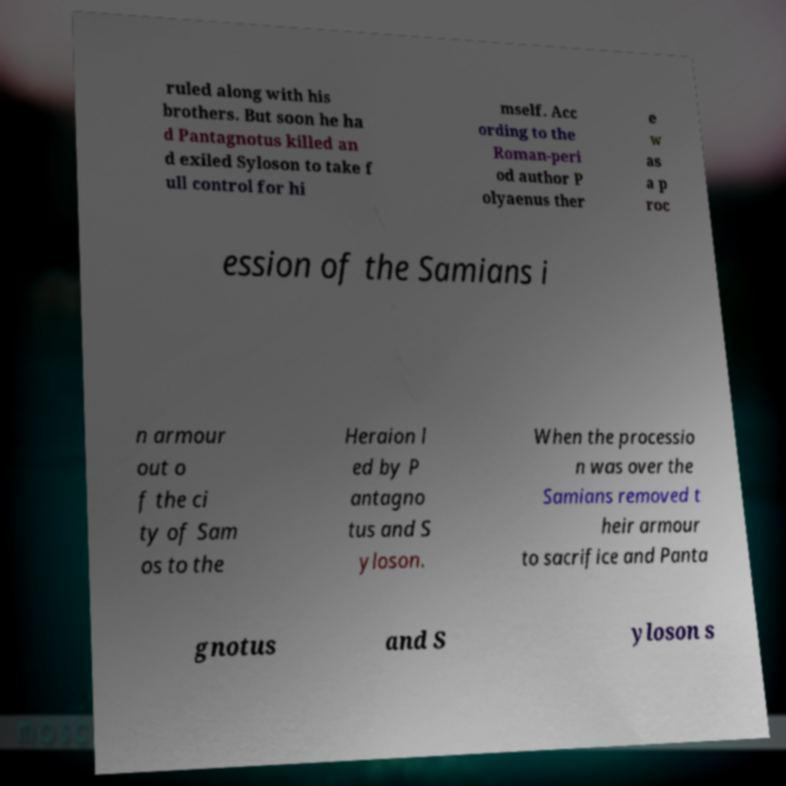Can you read and provide the text displayed in the image?This photo seems to have some interesting text. Can you extract and type it out for me? ruled along with his brothers. But soon he ha d Pantagnotus killed an d exiled Syloson to take f ull control for hi mself. Acc ording to the Roman-peri od author P olyaenus ther e w as a p roc ession of the Samians i n armour out o f the ci ty of Sam os to the Heraion l ed by P antagno tus and S yloson. When the processio n was over the Samians removed t heir armour to sacrifice and Panta gnotus and S yloson s 